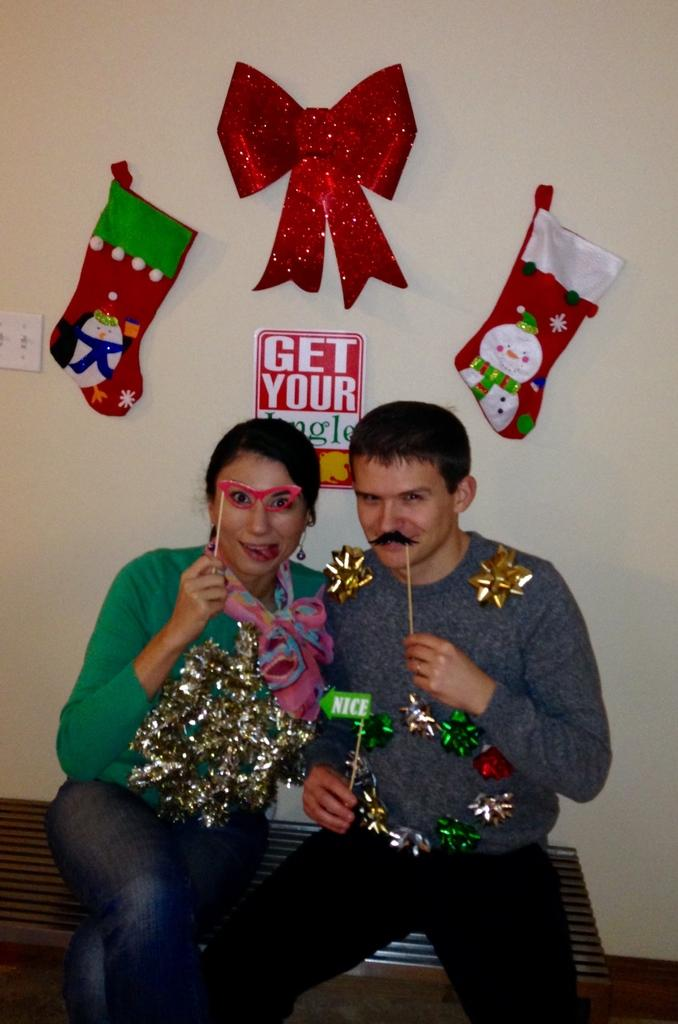How many people are sitting on the bench in the image? There are two persons sitting on a bench in the image. What can be seen in the background of the image? There are decorations and a switch board visible in the background, as well as a wall. What type of nerve is responsible for the arm movement in the image? There are no arms or arm movements depicted in the image, so it is not possible to determine which nerve might be responsible. 